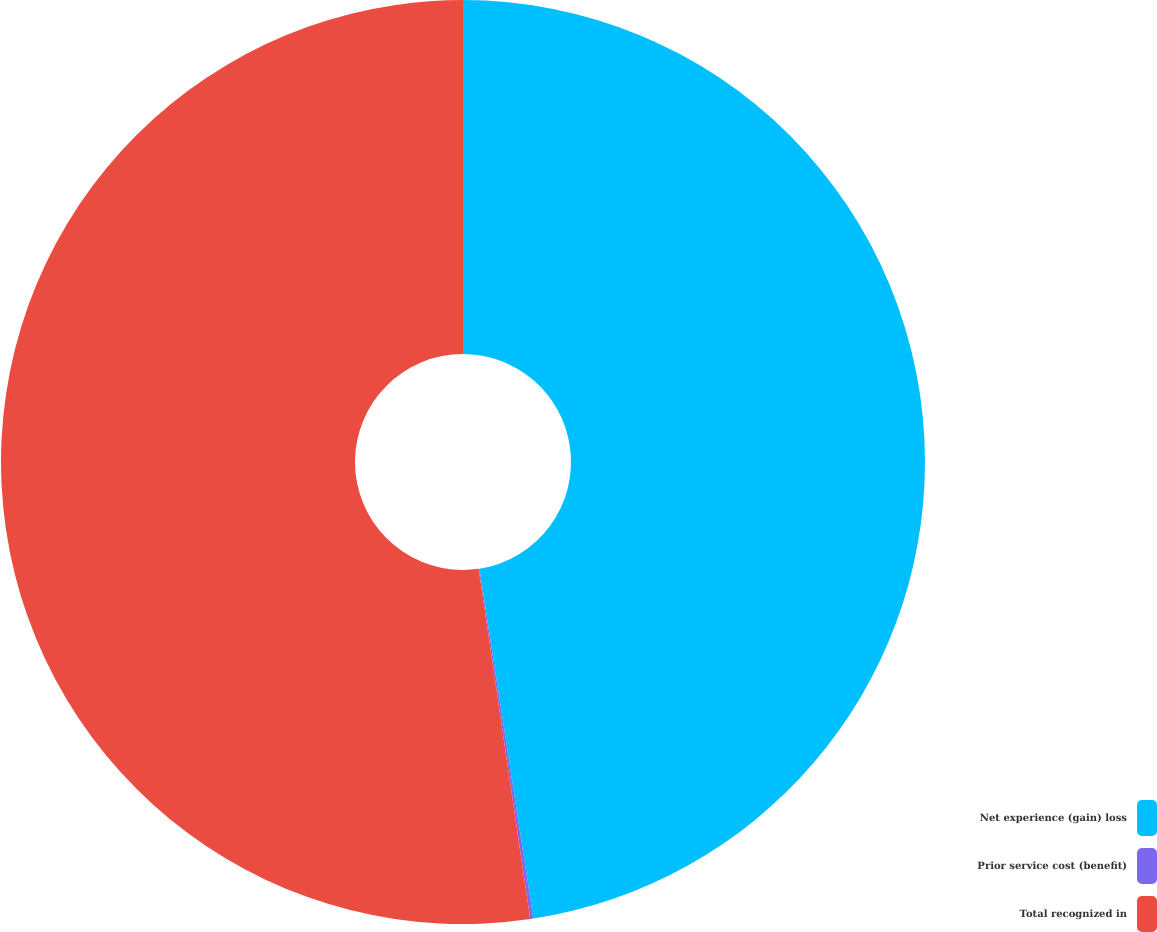Convert chart. <chart><loc_0><loc_0><loc_500><loc_500><pie_chart><fcel>Net experience (gain) loss<fcel>Prior service cost (benefit)<fcel>Total recognized in<nl><fcel>47.57%<fcel>0.11%<fcel>52.33%<nl></chart> 